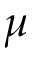<formula> <loc_0><loc_0><loc_500><loc_500>\mu</formula> 